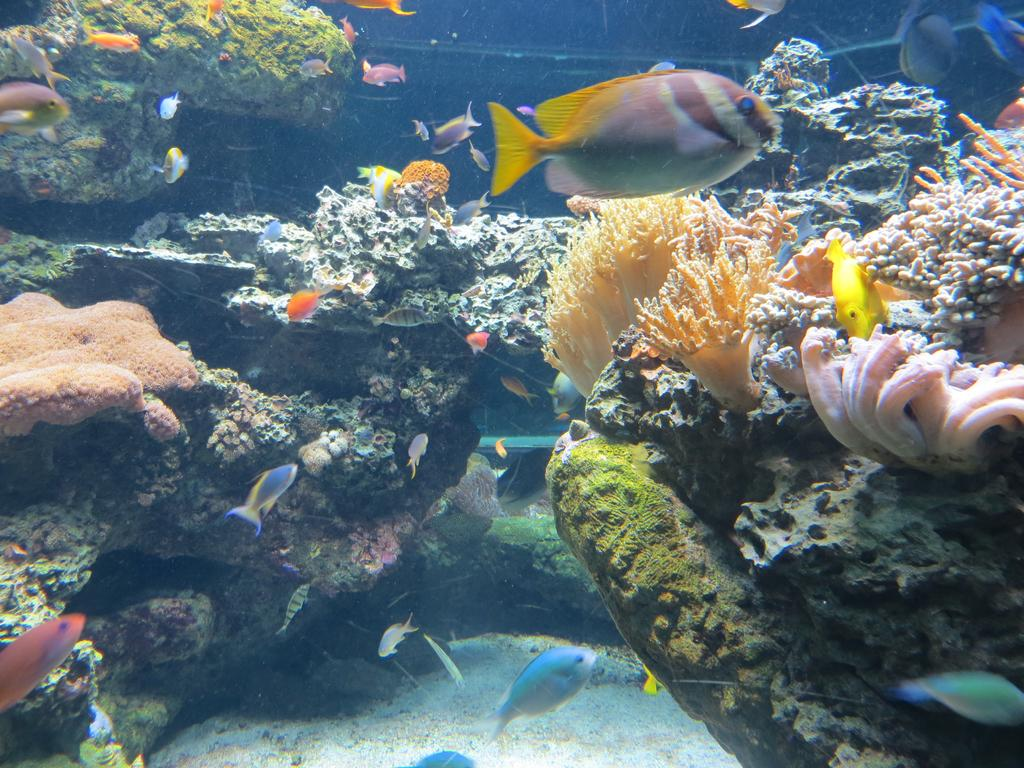What type of animals can be seen in the image? There are fishes in the image. What other objects or features can be seen in the image? There are corals and stones in the image. Where are these elements located? The fishes, corals, and stones are all in the water. What type of yak can be seen walking on the trail in the image? There is no yak or trail present in the image; it features fishes, corals, and stones in the water. 